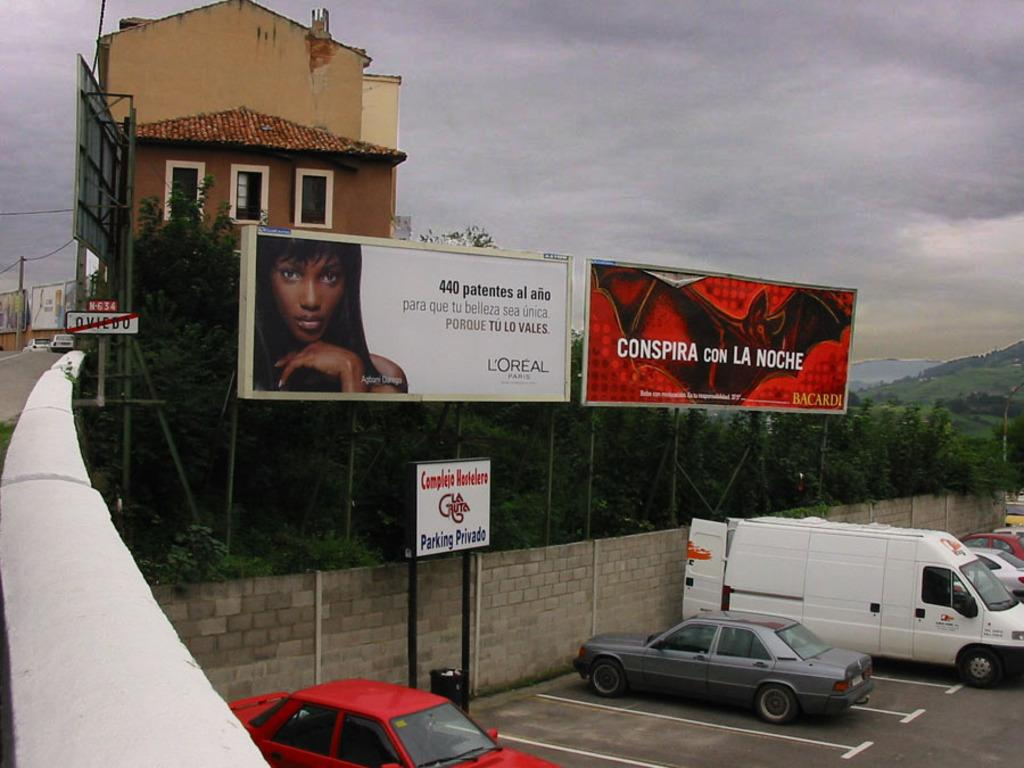<image>
Offer a succinct explanation of the picture presented. Two billboards, one for a cosmetics company, sit above a parking area and behind a house. 